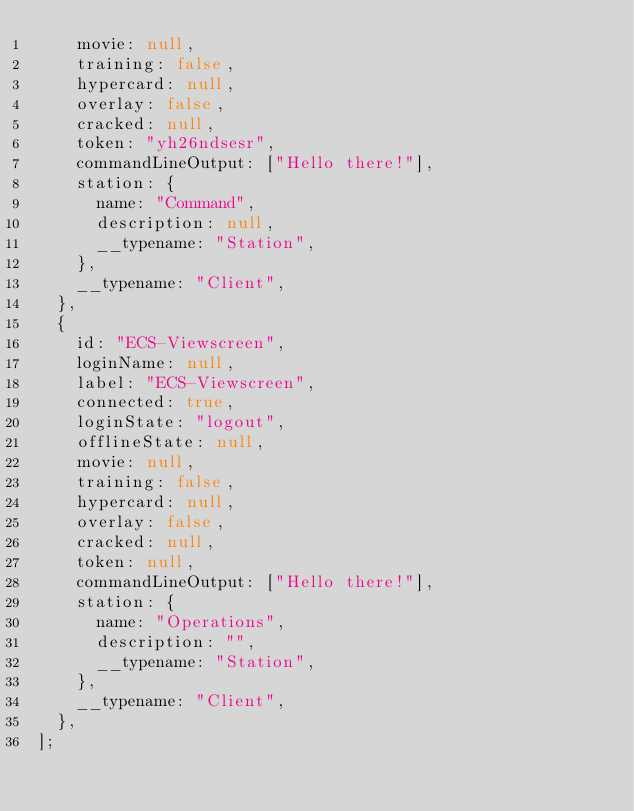Convert code to text. <code><loc_0><loc_0><loc_500><loc_500><_JavaScript_>    movie: null,
    training: false,
    hypercard: null,
    overlay: false,
    cracked: null,
    token: "yh26ndsesr",
    commandLineOutput: ["Hello there!"],
    station: {
      name: "Command",
      description: null,
      __typename: "Station",
    },
    __typename: "Client",
  },
  {
    id: "ECS-Viewscreen",
    loginName: null,
    label: "ECS-Viewscreen",
    connected: true,
    loginState: "logout",
    offlineState: null,
    movie: null,
    training: false,
    hypercard: null,
    overlay: false,
    cracked: null,
    token: null,
    commandLineOutput: ["Hello there!"],
    station: {
      name: "Operations",
      description: "",
      __typename: "Station",
    },
    __typename: "Client",
  },
];
</code> 